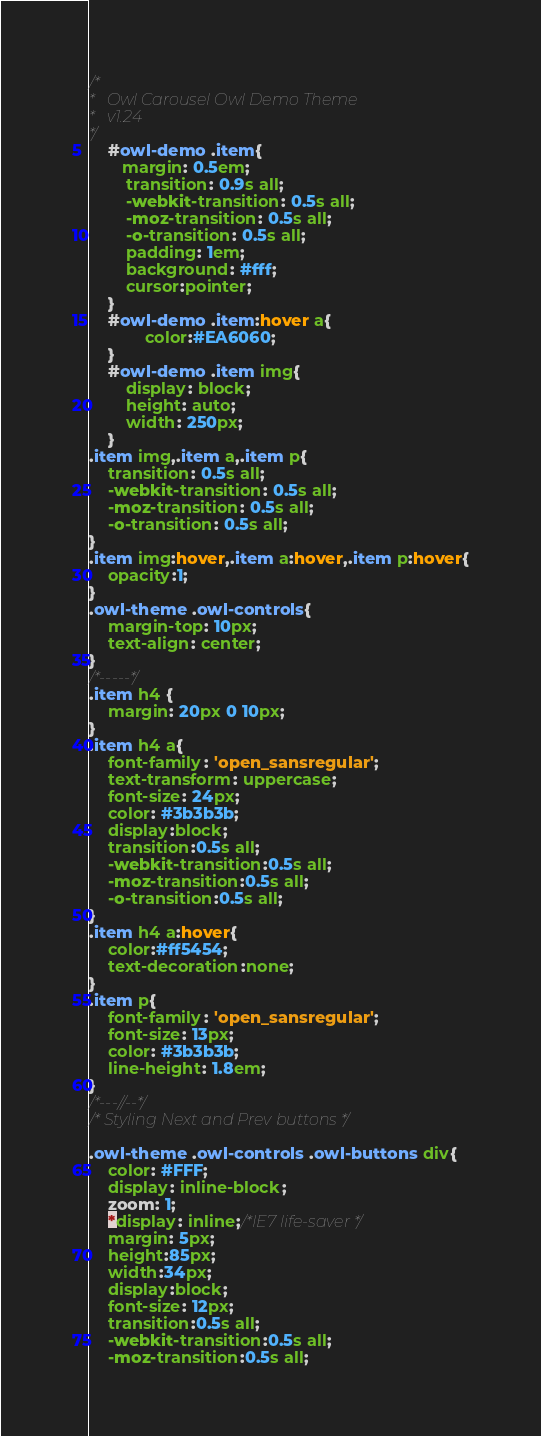<code> <loc_0><loc_0><loc_500><loc_500><_CSS_>/*
* 	Owl Carousel Owl Demo Theme 
*	v1.24
*/
    #owl-demo .item{
       margin: 0.5em;
		transition: 0.9s all;
		-webkit-transition: 0.5s all;
		-moz-transition: 0.5s all;
		-o-transition: 0.5s all;
		padding: 1em;
		background: #fff;
		cursor:pointer;
    }
    #owl-demo .item:hover a{
    		color:#EA6060;
    }
    #owl-demo .item img{
        display: block;
        height: auto;
        width: 250px;
    }
.item img,.item a,.item p{
	transition: 0.5s all;
	-webkit-transition: 0.5s all;
	-moz-transition: 0.5s all;
	-o-transition: 0.5s all;
}
.item img:hover,.item a:hover,.item p:hover{
	opacity:1;
}
.owl-theme .owl-controls{
	margin-top: 10px;
	text-align: center;
}
/*-----*/
.item h4 {
	margin: 20px 0 10px;
}
.item h4 a{
	font-family: 'open_sansregular';
	text-transform: uppercase;
	font-size: 24px;
	color: #3b3b3b;
	display:block;
	transition:0.5s all;
    -webkit-transition:0.5s all;
    -moz-transition:0.5s all;
    -o-transition:0.5s all;
}
.item h4 a:hover{
	color:#ff5454;
	text-decoration:none;
}
.item p{
	font-family: 'open_sansregular';
	font-size: 13px;
	color: #3b3b3b;
	line-height: 1.8em;
}
/*---//--*/
/* Styling Next and Prev buttons */

.owl-theme .owl-controls .owl-buttons div{
	color: #FFF;
	display: inline-block;
	zoom: 1;
	*display: inline;/*IE7 life-saver */
	margin: 5px;
	height:85px;
	width:34px;
	display:block;
	font-size: 12px;
	transition:0.5s all;
    -webkit-transition:0.5s all;
    -moz-transition:0.5s all;</code> 